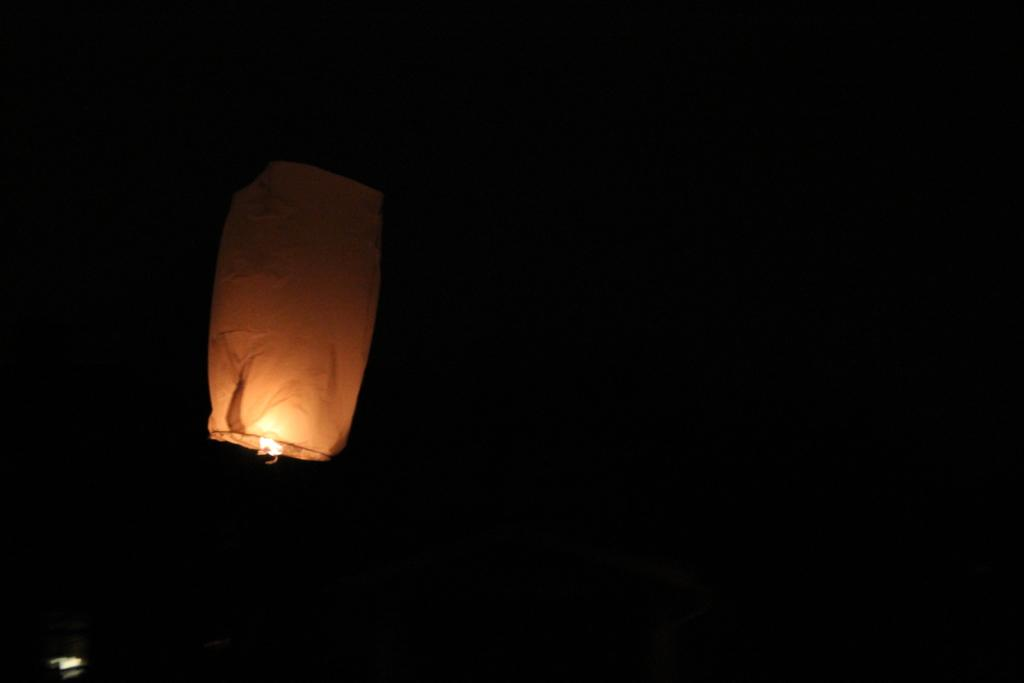What is the main object in the picture? There is a sky lantern in the picture. What color is the background of the image? The background of the image is black in color. What type of jeans is the sky lantern wearing in the image? There are no jeans present in the image, as the sky lantern is an inanimate object and cannot wear clothing. 